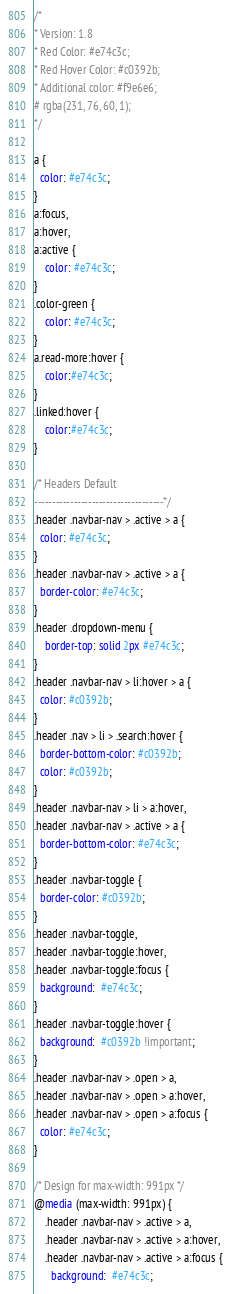<code> <loc_0><loc_0><loc_500><loc_500><_CSS_>/*
* Version: 1.8
* Red Color: #e74c3c;
* Red Hover Color: #c0392b;
* Additional color: #f9e6e6;
# rgba(231, 76, 60, 1);
*/

a {
  color: #e74c3c;
}
a:focus,
a:hover,
a:active {
	color: #e74c3c;
}
.color-green {
	color: #e74c3c;
}
a.read-more:hover {
	color:#e74c3c;
}
.linked:hover {
	color:#e74c3c;
}

/* Headers Default
------------------------------------*/
.header .navbar-nav > .active > a {
  color: #e74c3c;
}
.header .navbar-nav > .active > a {
  border-color: #e74c3c;
}
.header .dropdown-menu {
	border-top: solid 2px #e74c3c;
}
.header .navbar-nav > li:hover > a {
  color: #c0392b;
}
.header .nav > li > .search:hover {
  border-bottom-color: #c0392b;
  color: #c0392b;
}
.header .navbar-nav > li > a:hover,
.header .navbar-nav > .active > a {
  border-bottom-color: #e74c3c;
}
.header .navbar-toggle {
  border-color: #c0392b;
}
.header .navbar-toggle,
.header .navbar-toggle:hover,
.header .navbar-toggle:focus {
  background:  #e74c3c;
}
.header .navbar-toggle:hover {
  background:  #c0392b !important;
}
.header .navbar-nav > .open > a,
.header .navbar-nav > .open > a:hover,
.header .navbar-nav > .open > a:focus {
  color: #e74c3c;
}

/* Design for max-width: 991px */
@media (max-width: 991px) {
	.header .navbar-nav > .active > a,
	.header .navbar-nav > .active > a:hover,
	.header .navbar-nav > .active > a:focus {
	  background:  #e74c3c;</code> 